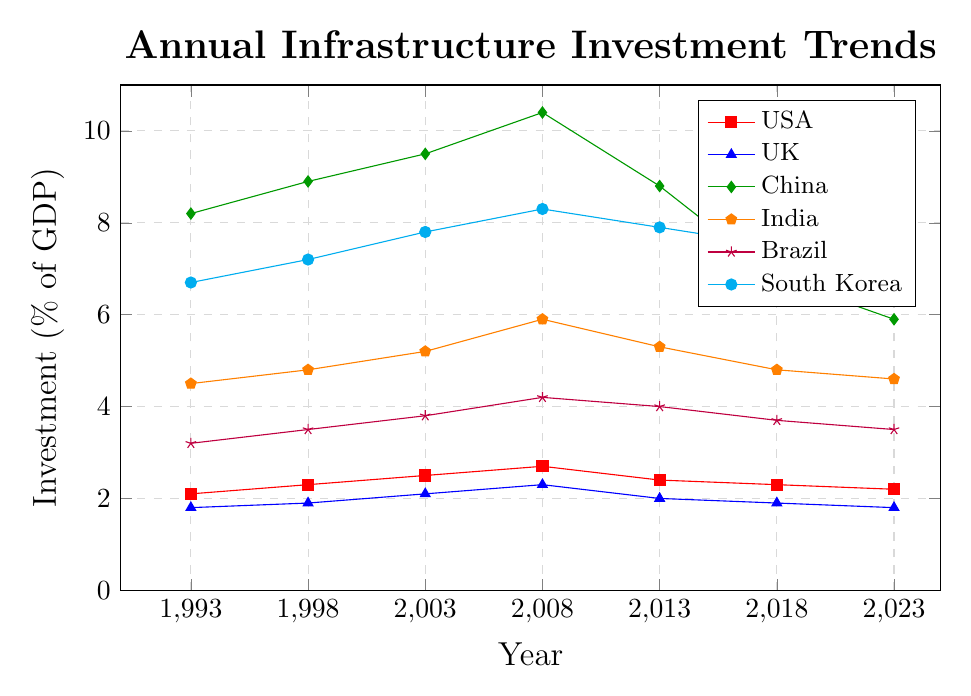What overall trend do you see in the infrastructure investment percentages for the USA? Visual inspection shows an initial increase until 2008 followed by a decrease till 2023. Identify the initial and peak values, noting the general trend.
Answer: Increase till 2008, then decrease Is the percentage of infrastructure investment in China in 2023 higher or lower than in 1993? Compare the data points for China in the years 1993 and 2023: 8.2% and 5.9%, respectively.
Answer: Lower Which country had the peak infrastructure investment as a percentage of GDP in 2008? Evaluate the values in 2008: USA (2.7), UK (2.3), China (10.4), India (5.9), Brazil (4.2), South Korea (8.3). China had the highest at 10.4%.
Answer: China Calculate the average infrastructure investment percentage over the 30 years for India. Calculate the mean of India's data points: (4.5 + 4.8 + 5.2 + 5.9 + 5.3 + 4.8 + 4.6) / 7 = 5.01%.
Answer: 5.01% Which year did South Korea have its highest investment in infrastructure as a percentage of GDP, and what was the value? Inspect each data point for South Korea: highest value is 8.3% in 2008.
Answer: 2008, 8.3% How does the trend in infrastructure investment in Brazil compare to that in the UK over the years? Observe the shape and direction of both lines. Brazil showed a slight increase peaking in 2013 and declining slightly, while the UK showed a slight increase till 2008 and then a decrease.
Answer: Brazil: slight increase, then decline; UK: slight increase till 2008, then decrease What is the difference between the highest and lowest infrastructure investment percentages for China? Identify the highest (10.4% in 2008) and lowest (5.9% in 2023) values, then calculate the difference: 10.4 - 5.9 = 4.5.
Answer: 4.5 Was the infrastructure investment in South Korea higher in 1998 or 2018? Compare the values for South Korea in 1998 (7.2) and 2018 (7.5).
Answer: 2018 